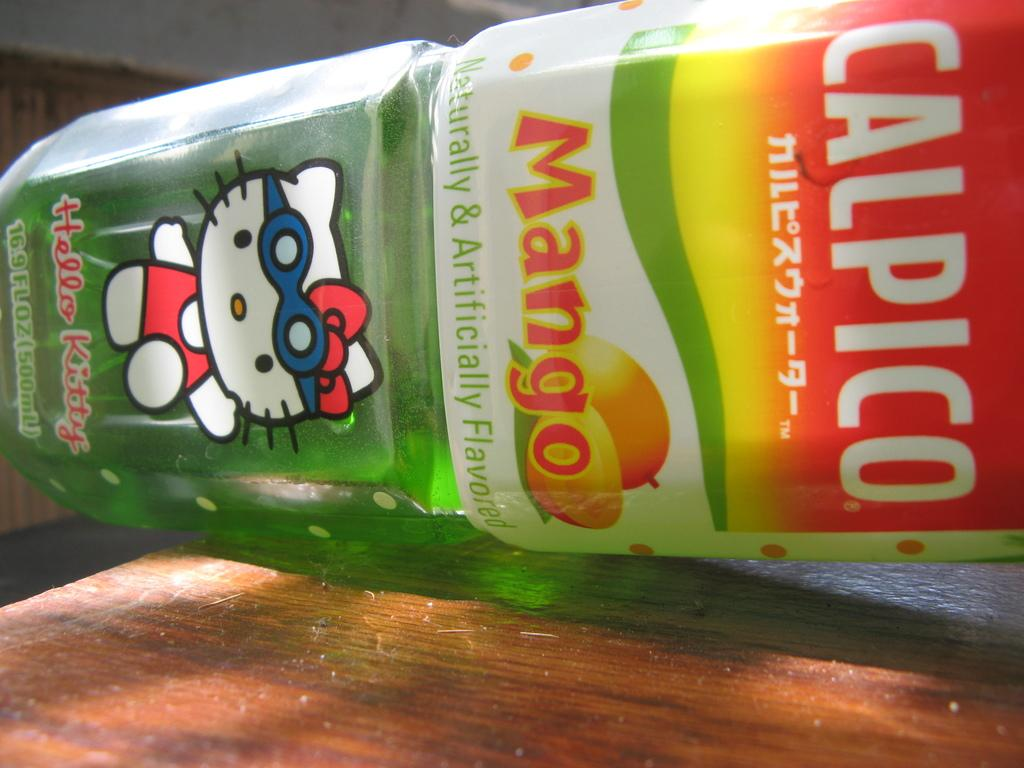<image>
Describe the image concisely. Calpico mango bottle of juice with a hello kitty image in front. 